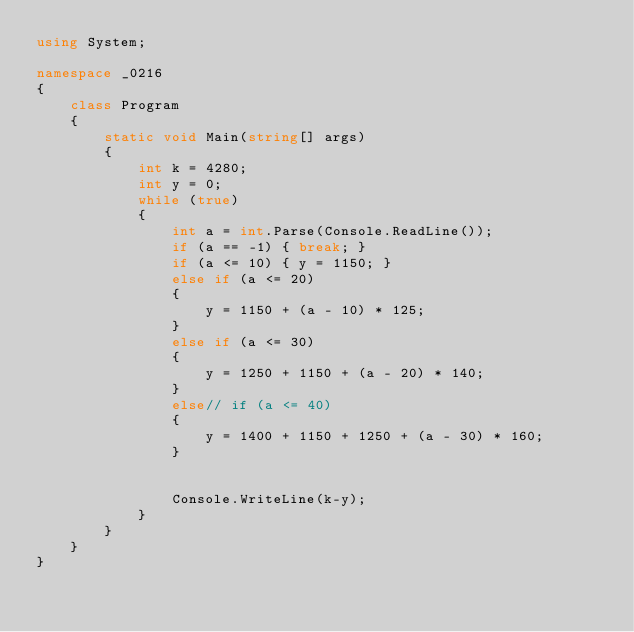<code> <loc_0><loc_0><loc_500><loc_500><_C#_>using System;

namespace _0216
{
    class Program
    {
        static void Main(string[] args)
        {
            int k = 4280;
            int y = 0;
            while (true)
            {
                int a = int.Parse(Console.ReadLine());
                if (a == -1) { break; }
                if (a <= 10) { y = 1150; }
                else if (a <= 20)
                {
                    y = 1150 + (a - 10) * 125;
                }
                else if (a <= 30)
                {
                    y = 1250 + 1150 + (a - 20) * 140;
                }
                else// if (a <= 40)
                {
                    y = 1400 + 1150 + 1250 + (a - 30) * 160;
                }


                Console.WriteLine(k-y);
            }
        }
    }
}</code> 